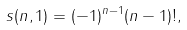<formula> <loc_0><loc_0><loc_500><loc_500>s ( n , 1 ) = ( - 1 ) ^ { n - 1 } ( n - 1 ) ! ,</formula> 